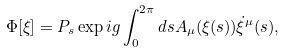Convert formula to latex. <formula><loc_0><loc_0><loc_500><loc_500>\Phi [ \xi ] = P _ { s } \exp i g \int _ { 0 } ^ { 2 \pi } d s A _ { \mu } ( \xi ( s ) ) \dot { \xi } ^ { \mu } ( s ) ,</formula> 